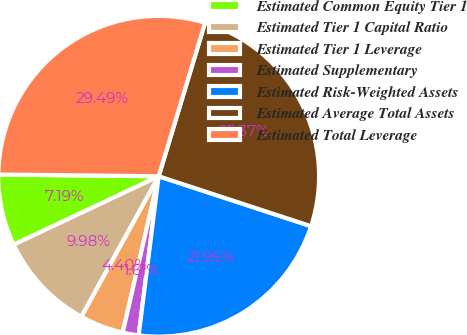Convert chart. <chart><loc_0><loc_0><loc_500><loc_500><pie_chart><fcel>Estimated Common Equity Tier 1<fcel>Estimated Tier 1 Capital Ratio<fcel>Estimated Tier 1 Leverage<fcel>Estimated Supplementary<fcel>Estimated Risk-Weighted Assets<fcel>Estimated Average Total Assets<fcel>Estimated Total Leverage<nl><fcel>7.19%<fcel>9.98%<fcel>4.4%<fcel>1.61%<fcel>21.95%<fcel>25.37%<fcel>29.49%<nl></chart> 